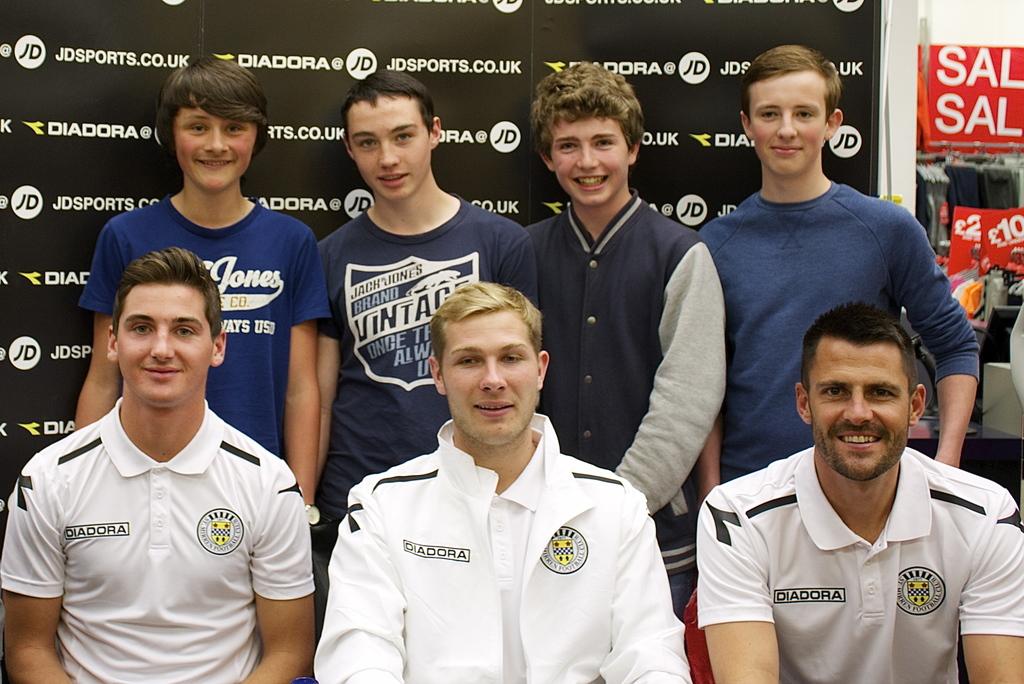What team are they for?
Provide a short and direct response. Unanswerable. 